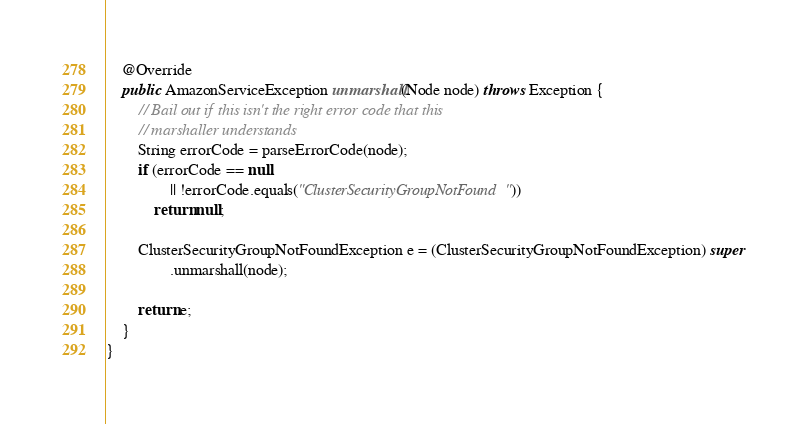<code> <loc_0><loc_0><loc_500><loc_500><_Java_>
    @Override
    public AmazonServiceException unmarshall(Node node) throws Exception {
        // Bail out if this isn't the right error code that this
        // marshaller understands
        String errorCode = parseErrorCode(node);
        if (errorCode == null
                || !errorCode.equals("ClusterSecurityGroupNotFound"))
            return null;

        ClusterSecurityGroupNotFoundException e = (ClusterSecurityGroupNotFoundException) super
                .unmarshall(node);

        return e;
    }
}
</code> 